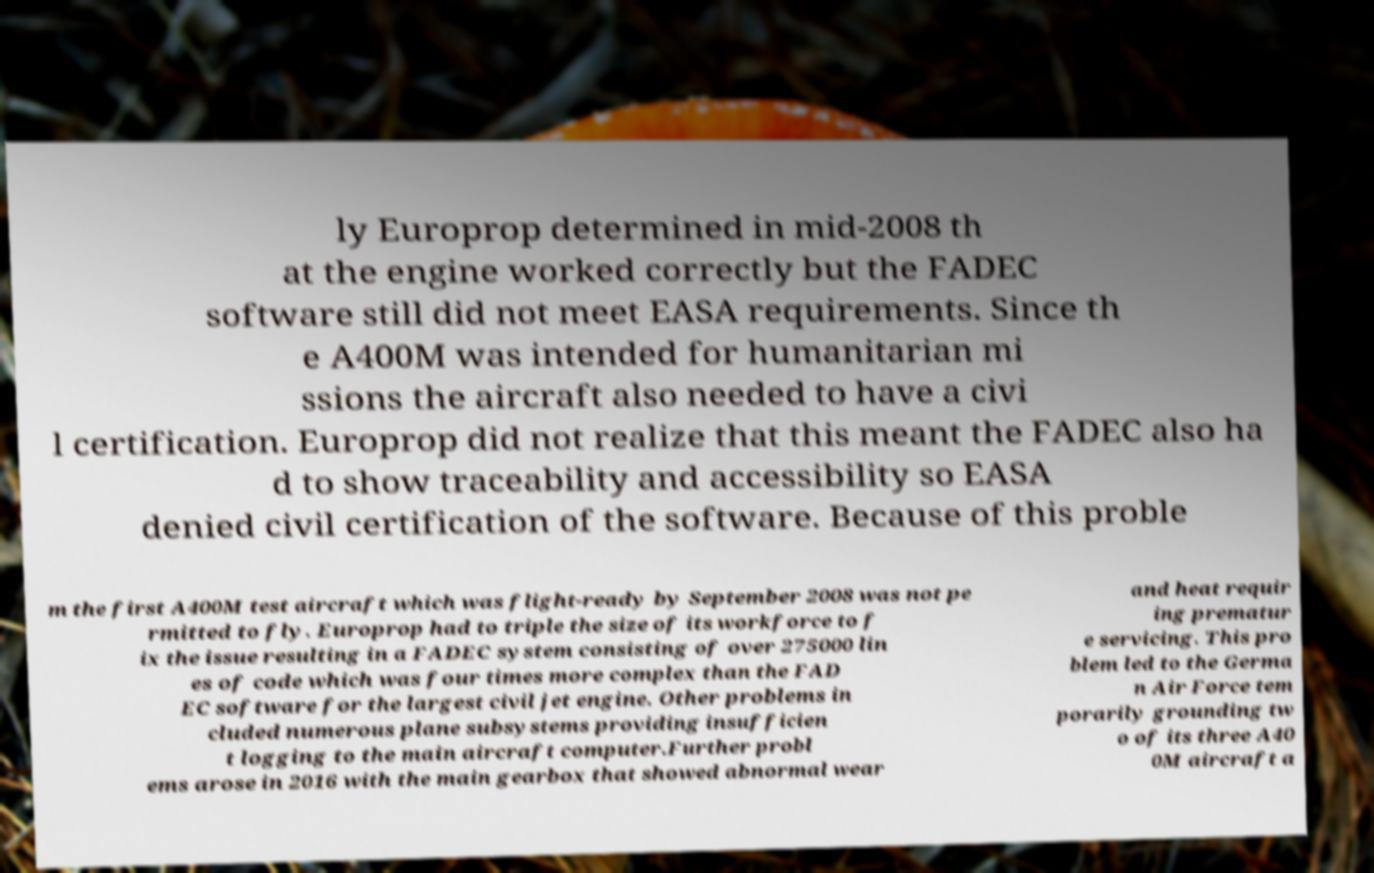What messages or text are displayed in this image? I need them in a readable, typed format. ly Europrop determined in mid-2008 th at the engine worked correctly but the FADEC software still did not meet EASA requirements. Since th e A400M was intended for humanitarian mi ssions the aircraft also needed to have a civi l certification. Europrop did not realize that this meant the FADEC also ha d to show traceability and accessibility so EASA denied civil certification of the software. Because of this proble m the first A400M test aircraft which was flight-ready by September 2008 was not pe rmitted to fly. Europrop had to triple the size of its workforce to f ix the issue resulting in a FADEC system consisting of over 275000 lin es of code which was four times more complex than the FAD EC software for the largest civil jet engine. Other problems in cluded numerous plane subsystems providing insufficien t logging to the main aircraft computer.Further probl ems arose in 2016 with the main gearbox that showed abnormal wear and heat requir ing prematur e servicing. This pro blem led to the Germa n Air Force tem porarily grounding tw o of its three A40 0M aircraft a 